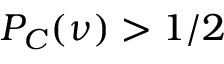<formula> <loc_0><loc_0><loc_500><loc_500>P _ { C } ( \nu ) > 1 / 2</formula> 